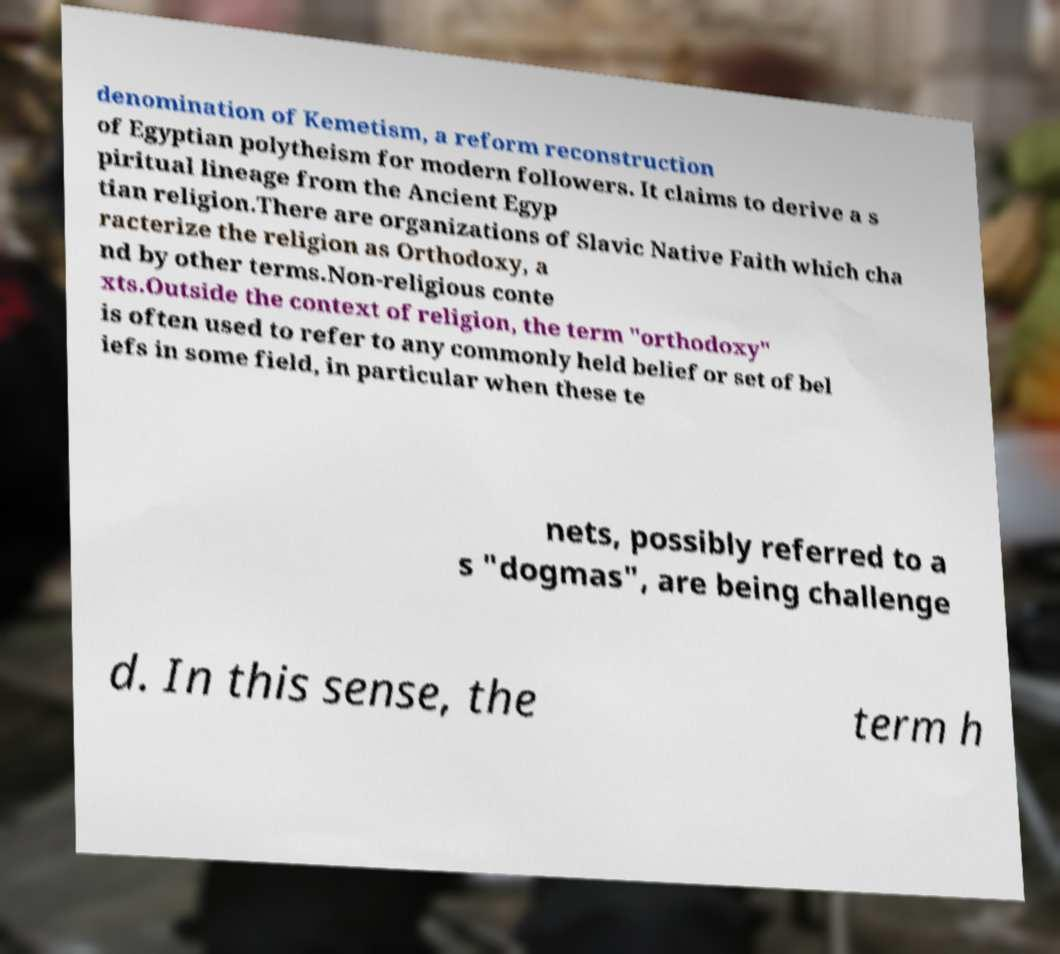There's text embedded in this image that I need extracted. Can you transcribe it verbatim? denomination of Kemetism, a reform reconstruction of Egyptian polytheism for modern followers. It claims to derive a s piritual lineage from the Ancient Egyp tian religion.There are organizations of Slavic Native Faith which cha racterize the religion as Orthodoxy, a nd by other terms.Non-religious conte xts.Outside the context of religion, the term "orthodoxy" is often used to refer to any commonly held belief or set of bel iefs in some field, in particular when these te nets, possibly referred to a s "dogmas", are being challenge d. In this sense, the term h 